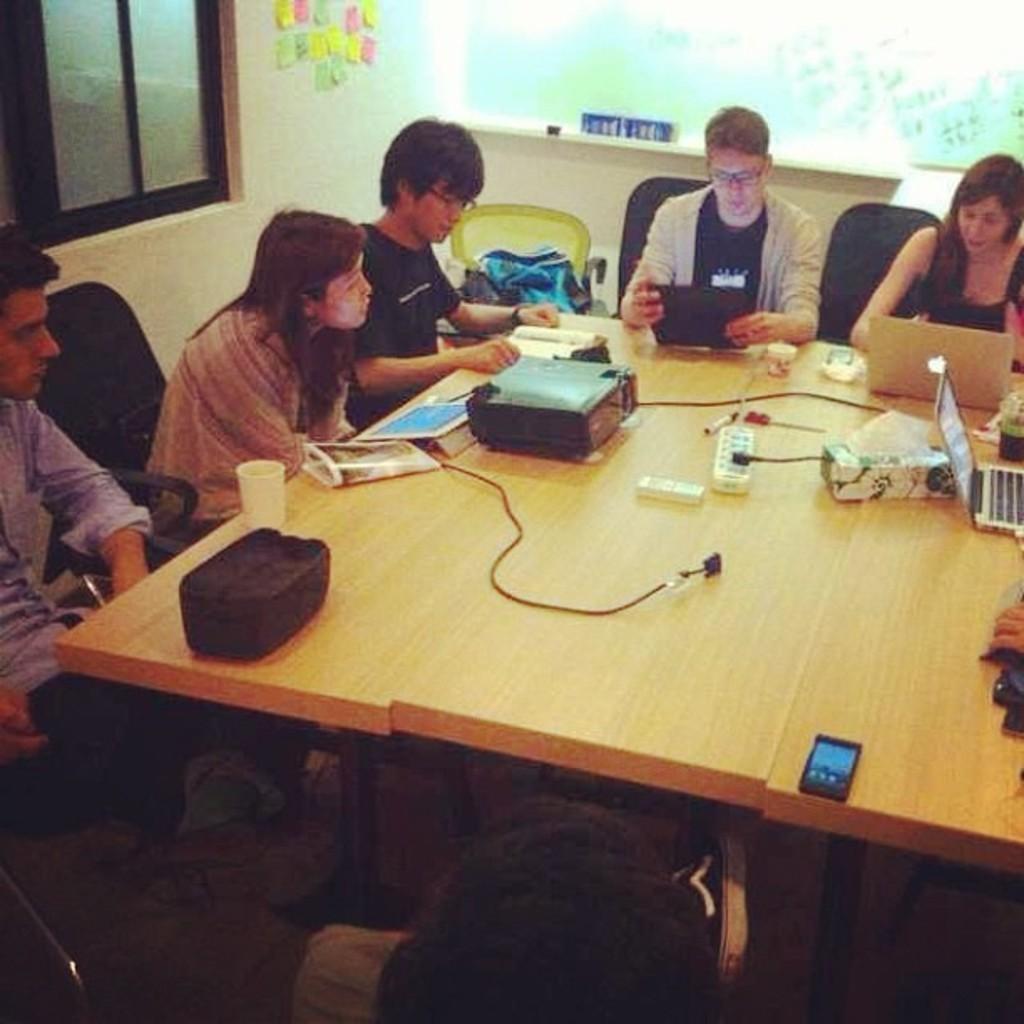Please provide a concise description of this image. On the table we can see projector, cables, socket, tissue papers, tissue box, laptops, mobile phone, book, file, papers, water glass, pen, scissor, cup bowl and other object. On the right there is a woman who is sitting on the chair and looking in the laptop. Beside her we can see a man who is wearing spectacle, hoodie and t-shirt. On the left we can see a man who is sitting near to the woman. Beside her we can see another man who is wearing black t-shirt and spectacle. This three persons are sitting near to the window. Here we can see clothes on yellow chair. 